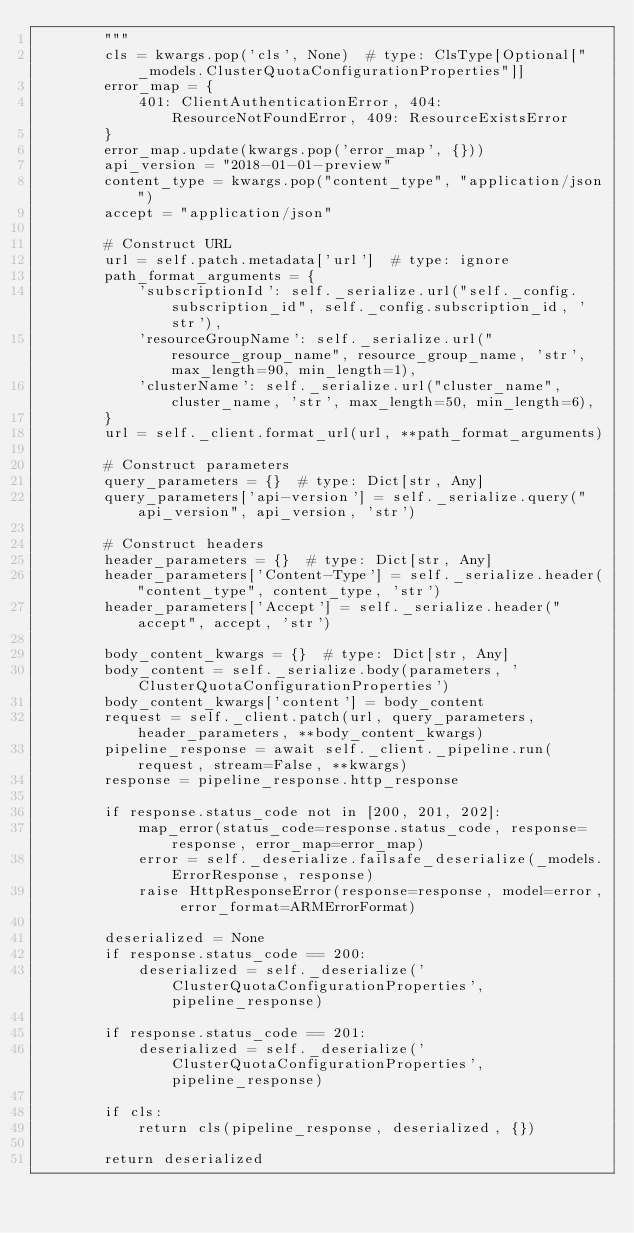<code> <loc_0><loc_0><loc_500><loc_500><_Python_>        """
        cls = kwargs.pop('cls', None)  # type: ClsType[Optional["_models.ClusterQuotaConfigurationProperties"]]
        error_map = {
            401: ClientAuthenticationError, 404: ResourceNotFoundError, 409: ResourceExistsError
        }
        error_map.update(kwargs.pop('error_map', {}))
        api_version = "2018-01-01-preview"
        content_type = kwargs.pop("content_type", "application/json")
        accept = "application/json"

        # Construct URL
        url = self.patch.metadata['url']  # type: ignore
        path_format_arguments = {
            'subscriptionId': self._serialize.url("self._config.subscription_id", self._config.subscription_id, 'str'),
            'resourceGroupName': self._serialize.url("resource_group_name", resource_group_name, 'str', max_length=90, min_length=1),
            'clusterName': self._serialize.url("cluster_name", cluster_name, 'str', max_length=50, min_length=6),
        }
        url = self._client.format_url(url, **path_format_arguments)

        # Construct parameters
        query_parameters = {}  # type: Dict[str, Any]
        query_parameters['api-version'] = self._serialize.query("api_version", api_version, 'str')

        # Construct headers
        header_parameters = {}  # type: Dict[str, Any]
        header_parameters['Content-Type'] = self._serialize.header("content_type", content_type, 'str')
        header_parameters['Accept'] = self._serialize.header("accept", accept, 'str')

        body_content_kwargs = {}  # type: Dict[str, Any]
        body_content = self._serialize.body(parameters, 'ClusterQuotaConfigurationProperties')
        body_content_kwargs['content'] = body_content
        request = self._client.patch(url, query_parameters, header_parameters, **body_content_kwargs)
        pipeline_response = await self._client._pipeline.run(request, stream=False, **kwargs)
        response = pipeline_response.http_response

        if response.status_code not in [200, 201, 202]:
            map_error(status_code=response.status_code, response=response, error_map=error_map)
            error = self._deserialize.failsafe_deserialize(_models.ErrorResponse, response)
            raise HttpResponseError(response=response, model=error, error_format=ARMErrorFormat)

        deserialized = None
        if response.status_code == 200:
            deserialized = self._deserialize('ClusterQuotaConfigurationProperties', pipeline_response)

        if response.status_code == 201:
            deserialized = self._deserialize('ClusterQuotaConfigurationProperties', pipeline_response)

        if cls:
            return cls(pipeline_response, deserialized, {})

        return deserialized</code> 